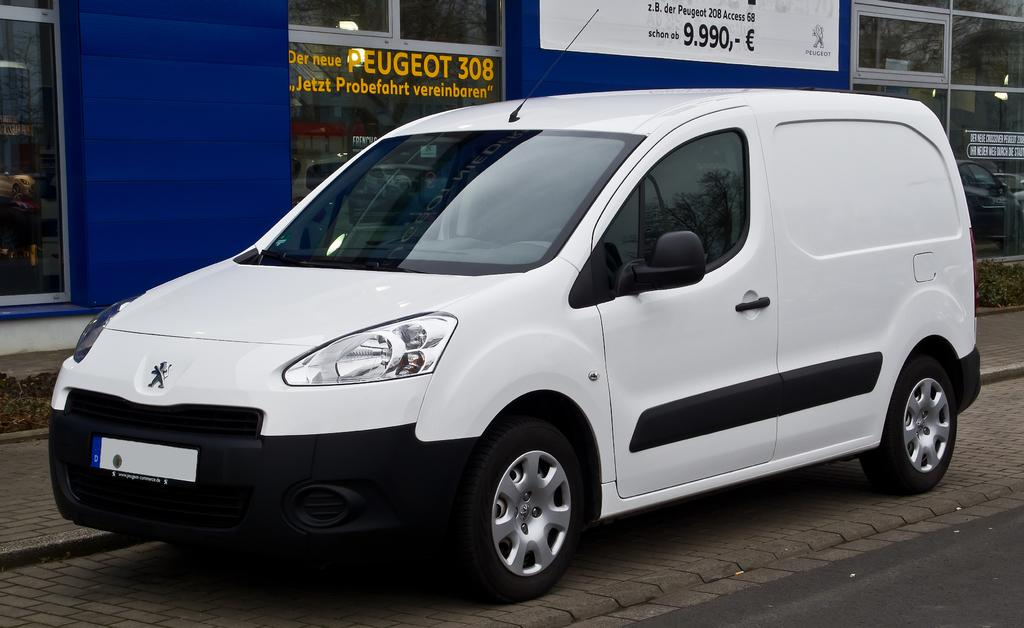<image>
Present a compact description of the photo's key features. A white vehicle is in front of a window with the word Peugeot on it. 